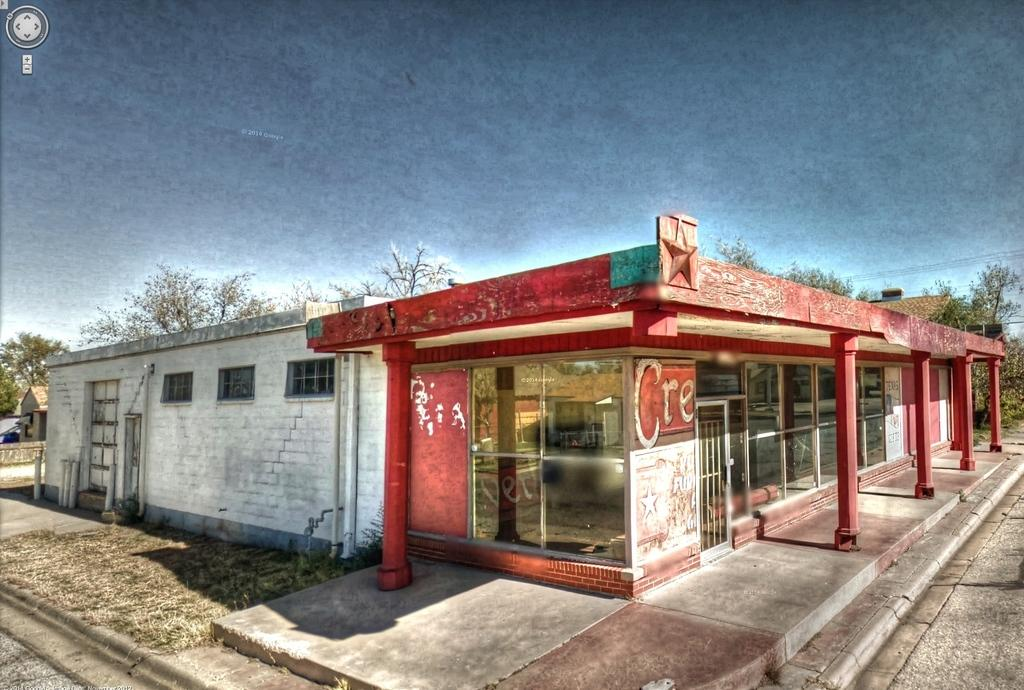What is located in the foreground of the image? There is a building in the foreground of the image. What else can be seen in the foreground of the image? There is a side path to walk in the foreground of the image. What type of vegetation is visible at the top of the image? There are trees visible at the top of the image. What is visible above the trees in the image? The sky is visible at the top of the image. How many pizzas are being hammered by the tiger in the image? There are no pizzas or tigers present in the image. 